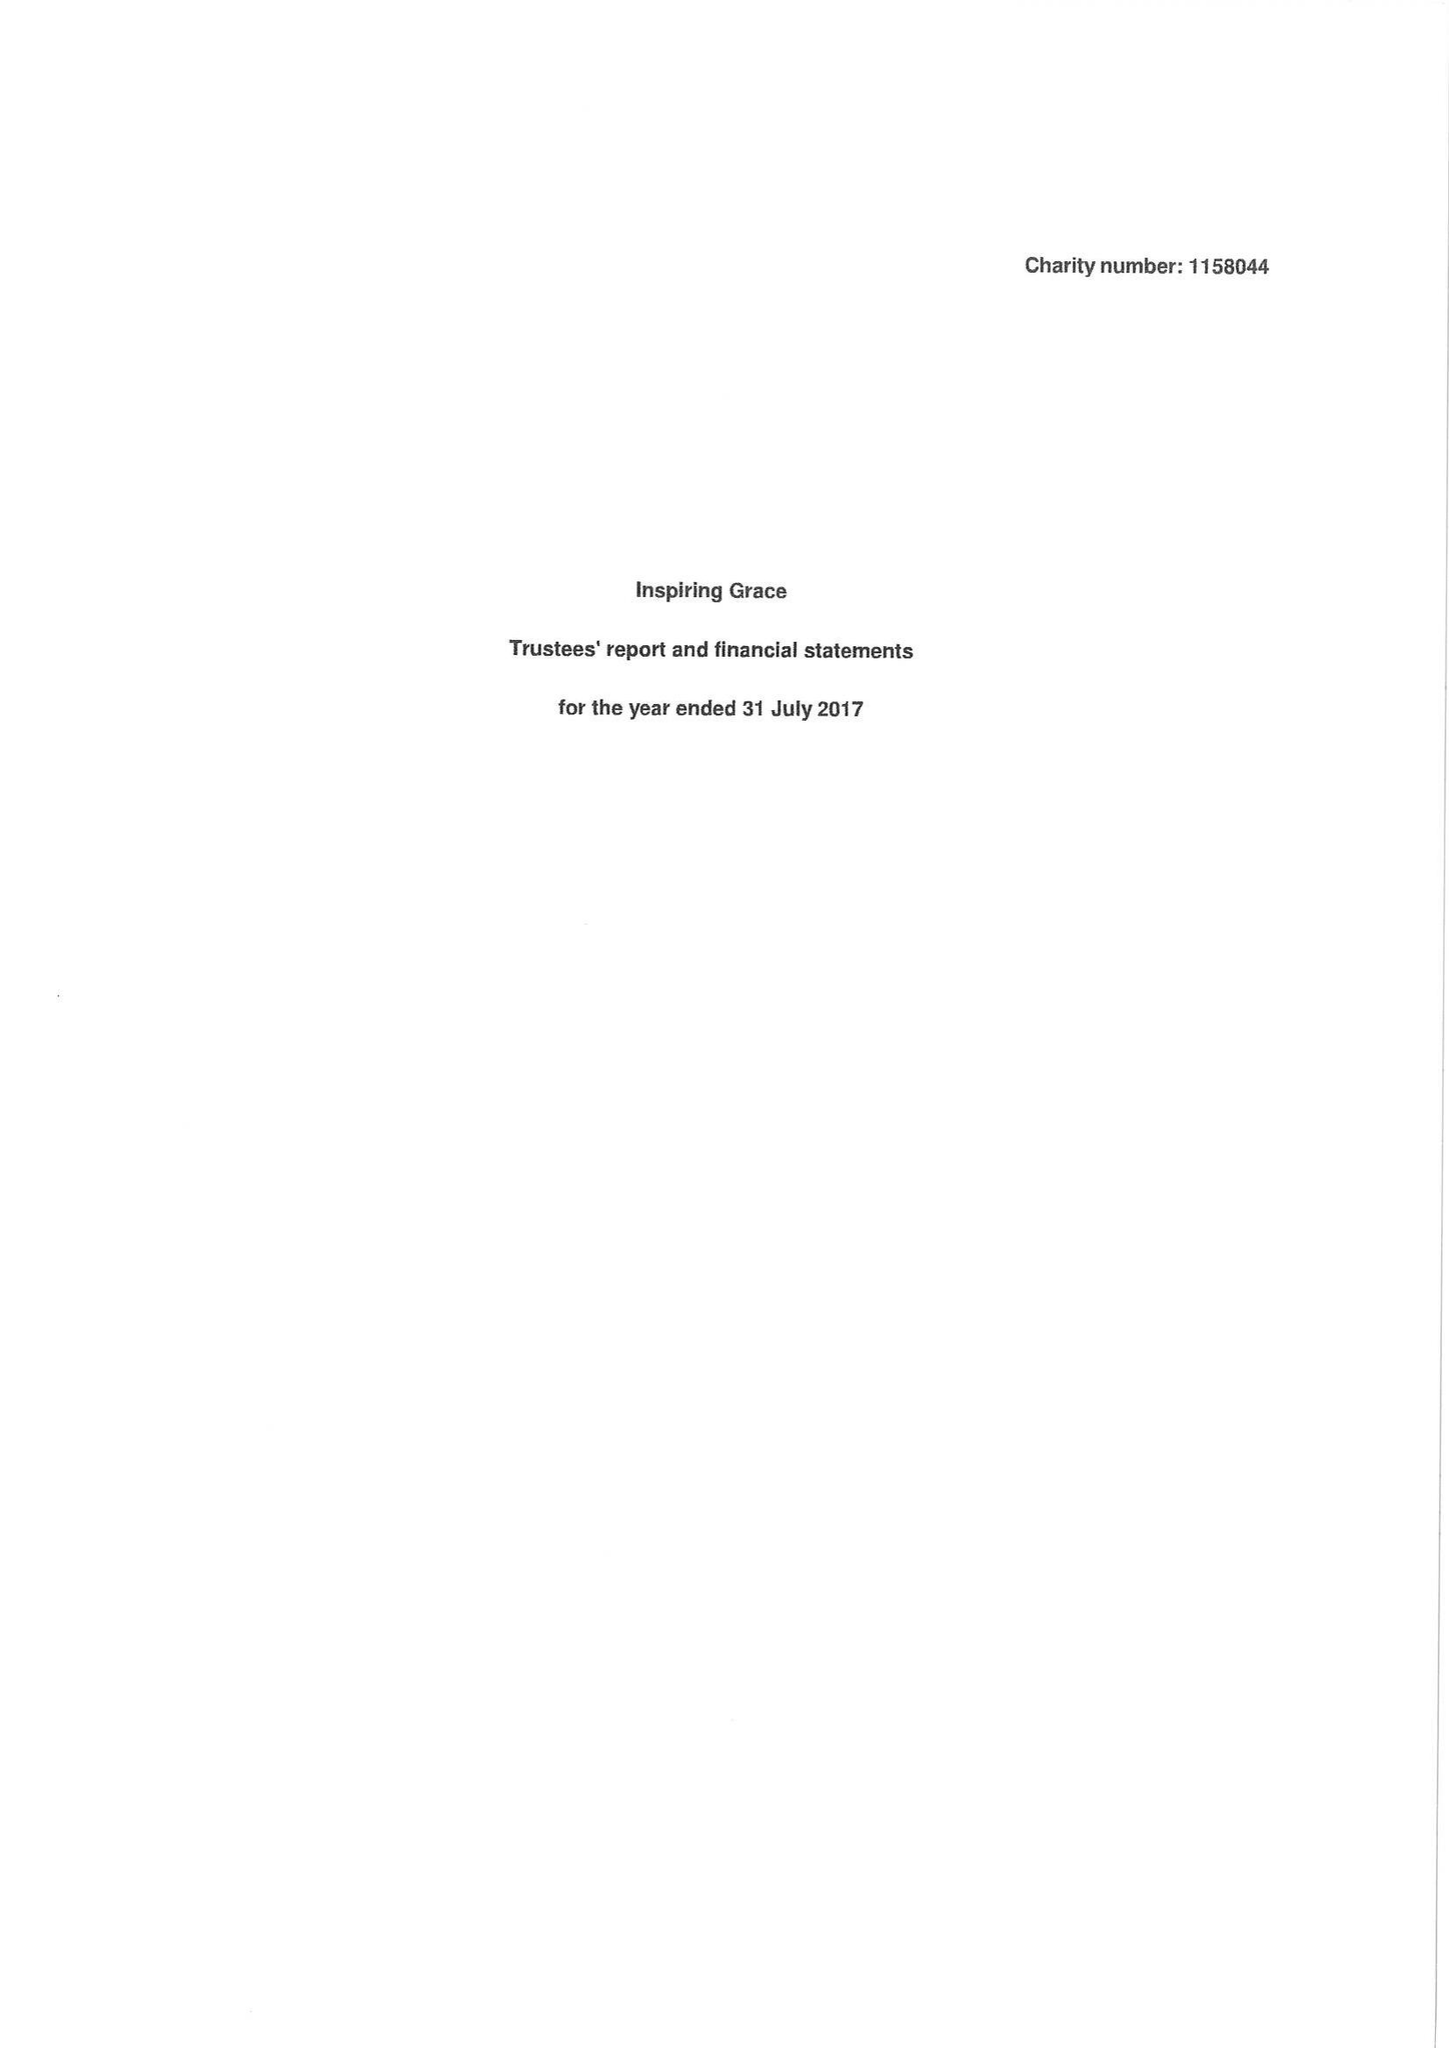What is the value for the address__postcode?
Answer the question using a single word or phrase. BB9 8RT 